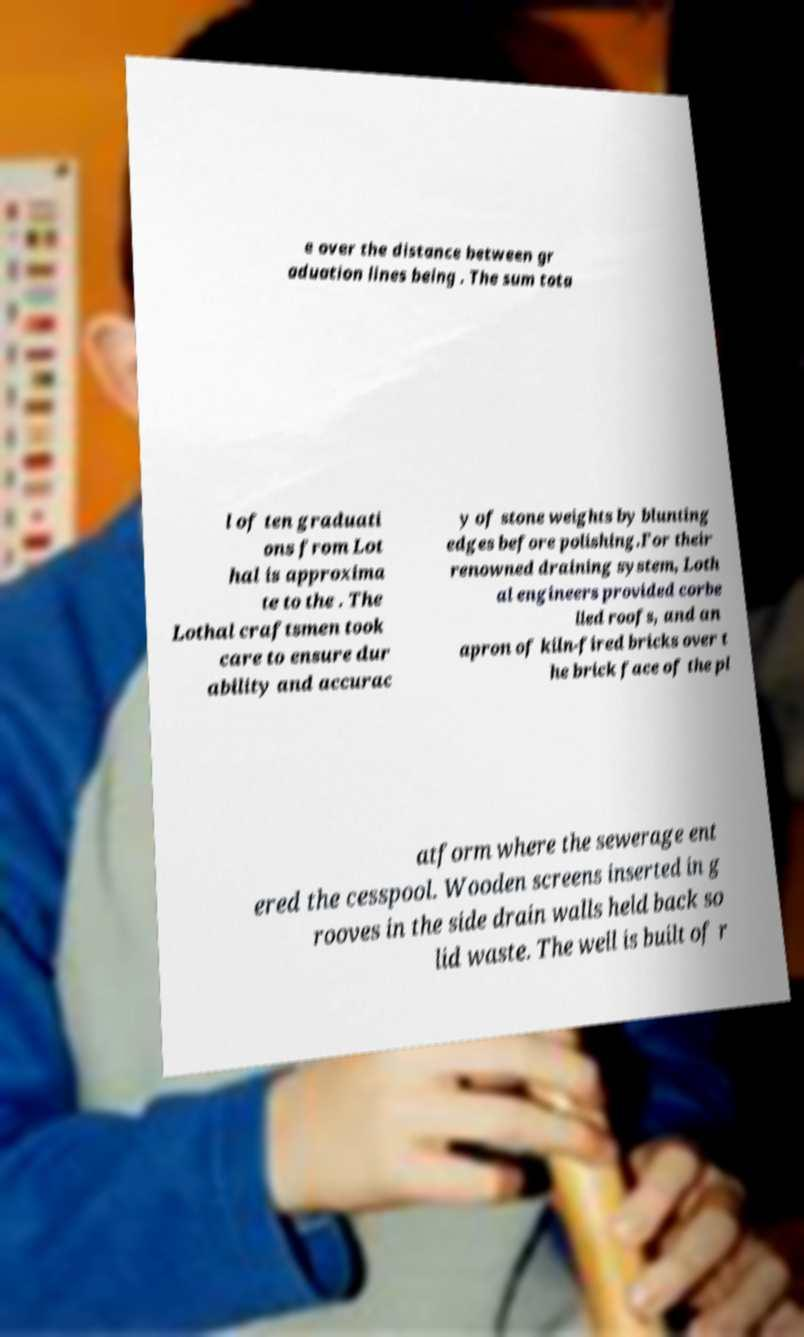Can you accurately transcribe the text from the provided image for me? e over the distance between gr aduation lines being . The sum tota l of ten graduati ons from Lot hal is approxima te to the . The Lothal craftsmen took care to ensure dur ability and accurac y of stone weights by blunting edges before polishing.For their renowned draining system, Loth al engineers provided corbe lled roofs, and an apron of kiln-fired bricks over t he brick face of the pl atform where the sewerage ent ered the cesspool. Wooden screens inserted in g rooves in the side drain walls held back so lid waste. The well is built of r 